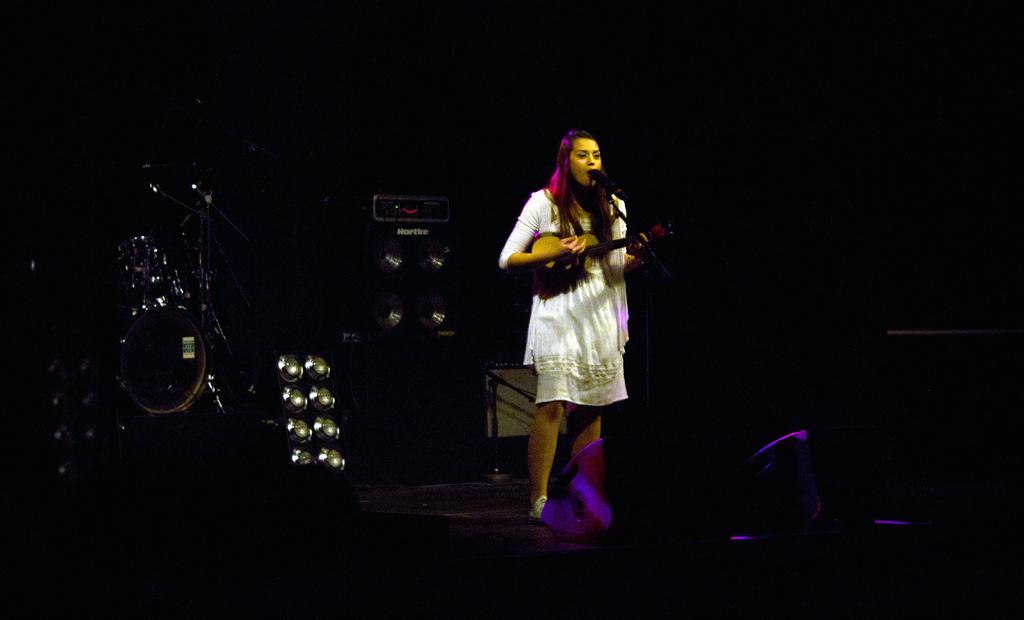What is the person in the image doing? The person is playing a guitar and singing. What is the person wearing? The person is wearing a white dress. What can be seen behind the person? There are speakers visible behind the person. How long does it take for the person to begin playing the guitar in space? The image does not depict the person playing the guitar in space, and there is no indication of time or duration related to the person's actions. 